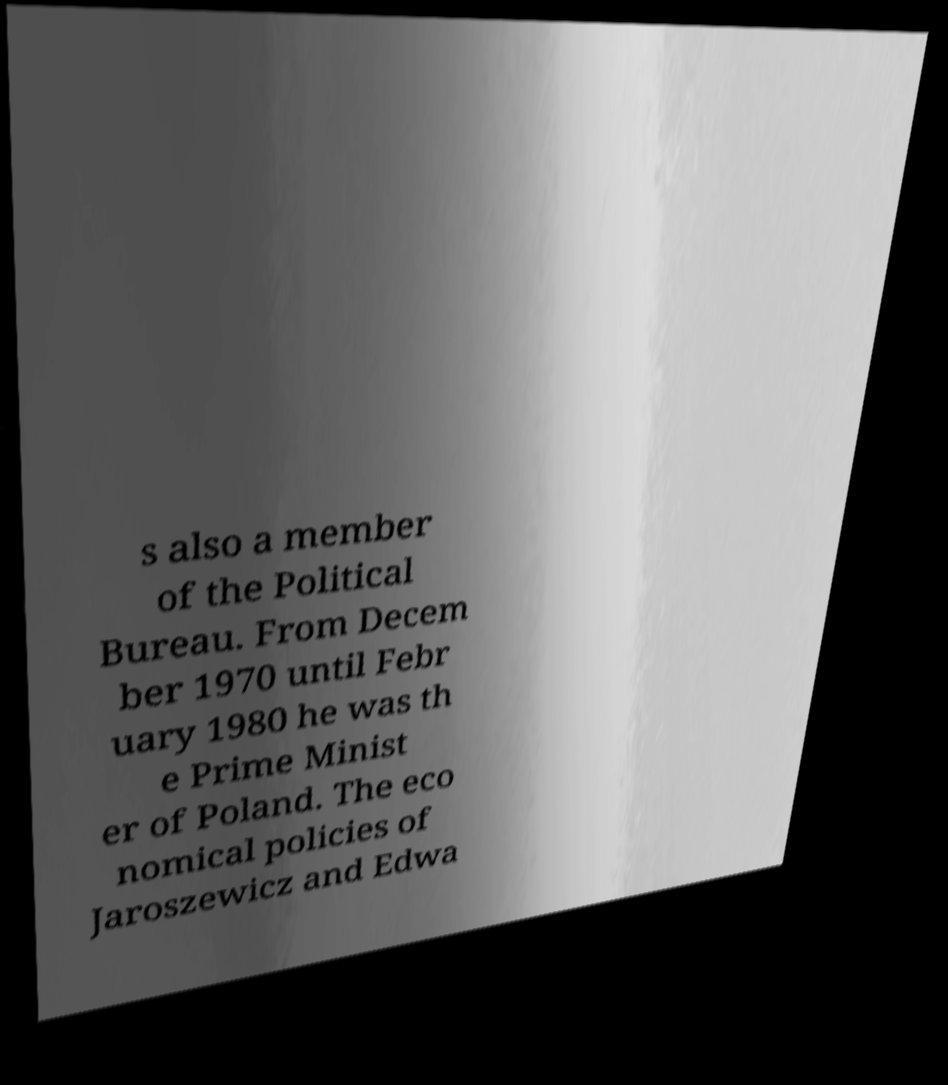For documentation purposes, I need the text within this image transcribed. Could you provide that? s also a member of the Political Bureau. From Decem ber 1970 until Febr uary 1980 he was th e Prime Minist er of Poland. The eco nomical policies of Jaroszewicz and Edwa 